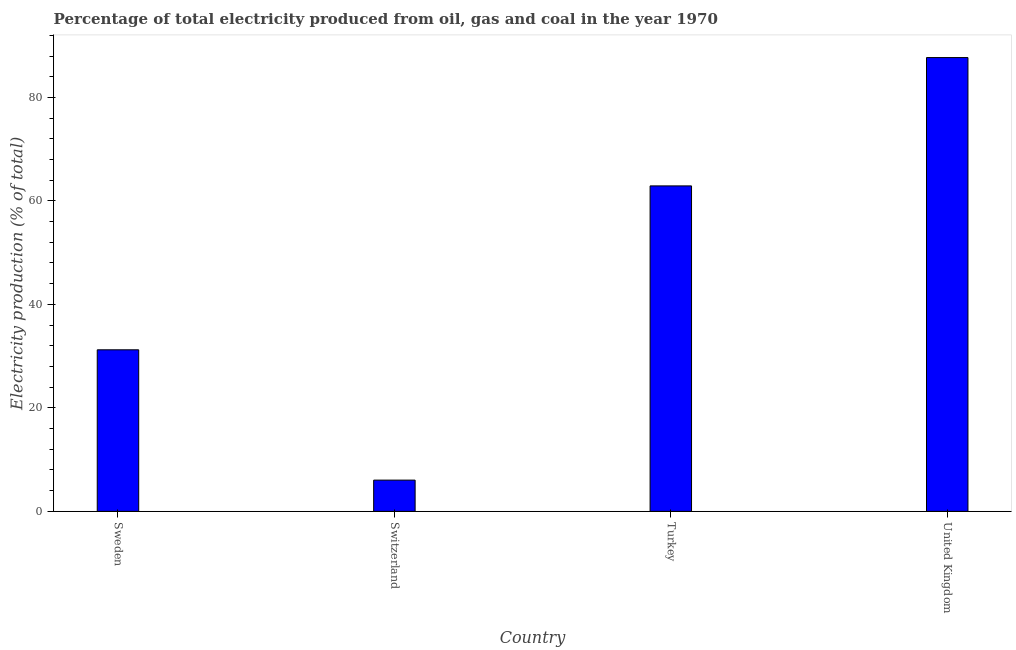What is the title of the graph?
Your answer should be compact. Percentage of total electricity produced from oil, gas and coal in the year 1970. What is the label or title of the X-axis?
Offer a terse response. Country. What is the label or title of the Y-axis?
Give a very brief answer. Electricity production (% of total). What is the electricity production in Sweden?
Keep it short and to the point. 31.22. Across all countries, what is the maximum electricity production?
Offer a terse response. 87.7. Across all countries, what is the minimum electricity production?
Give a very brief answer. 6.04. In which country was the electricity production maximum?
Provide a short and direct response. United Kingdom. In which country was the electricity production minimum?
Provide a short and direct response. Switzerland. What is the sum of the electricity production?
Keep it short and to the point. 187.87. What is the difference between the electricity production in Sweden and Switzerland?
Ensure brevity in your answer.  25.19. What is the average electricity production per country?
Keep it short and to the point. 46.97. What is the median electricity production?
Give a very brief answer. 47.06. What is the ratio of the electricity production in Switzerland to that in Turkey?
Make the answer very short. 0.1. Is the electricity production in Turkey less than that in United Kingdom?
Your answer should be compact. Yes. Is the difference between the electricity production in Sweden and Switzerland greater than the difference between any two countries?
Ensure brevity in your answer.  No. What is the difference between the highest and the second highest electricity production?
Offer a terse response. 24.8. Is the sum of the electricity production in Turkey and United Kingdom greater than the maximum electricity production across all countries?
Ensure brevity in your answer.  Yes. What is the difference between the highest and the lowest electricity production?
Your response must be concise. 81.66. In how many countries, is the electricity production greater than the average electricity production taken over all countries?
Offer a terse response. 2. Are all the bars in the graph horizontal?
Offer a terse response. No. How many countries are there in the graph?
Ensure brevity in your answer.  4. Are the values on the major ticks of Y-axis written in scientific E-notation?
Provide a short and direct response. No. What is the Electricity production (% of total) in Sweden?
Your response must be concise. 31.22. What is the Electricity production (% of total) in Switzerland?
Provide a short and direct response. 6.04. What is the Electricity production (% of total) in Turkey?
Your answer should be compact. 62.9. What is the Electricity production (% of total) of United Kingdom?
Offer a terse response. 87.7. What is the difference between the Electricity production (% of total) in Sweden and Switzerland?
Give a very brief answer. 25.19. What is the difference between the Electricity production (% of total) in Sweden and Turkey?
Offer a very short reply. -31.68. What is the difference between the Electricity production (% of total) in Sweden and United Kingdom?
Keep it short and to the point. -56.48. What is the difference between the Electricity production (% of total) in Switzerland and Turkey?
Keep it short and to the point. -56.86. What is the difference between the Electricity production (% of total) in Switzerland and United Kingdom?
Ensure brevity in your answer.  -81.66. What is the difference between the Electricity production (% of total) in Turkey and United Kingdom?
Ensure brevity in your answer.  -24.8. What is the ratio of the Electricity production (% of total) in Sweden to that in Switzerland?
Offer a terse response. 5.17. What is the ratio of the Electricity production (% of total) in Sweden to that in Turkey?
Make the answer very short. 0.5. What is the ratio of the Electricity production (% of total) in Sweden to that in United Kingdom?
Your answer should be very brief. 0.36. What is the ratio of the Electricity production (% of total) in Switzerland to that in Turkey?
Offer a very short reply. 0.1. What is the ratio of the Electricity production (% of total) in Switzerland to that in United Kingdom?
Offer a terse response. 0.07. What is the ratio of the Electricity production (% of total) in Turkey to that in United Kingdom?
Your answer should be compact. 0.72. 